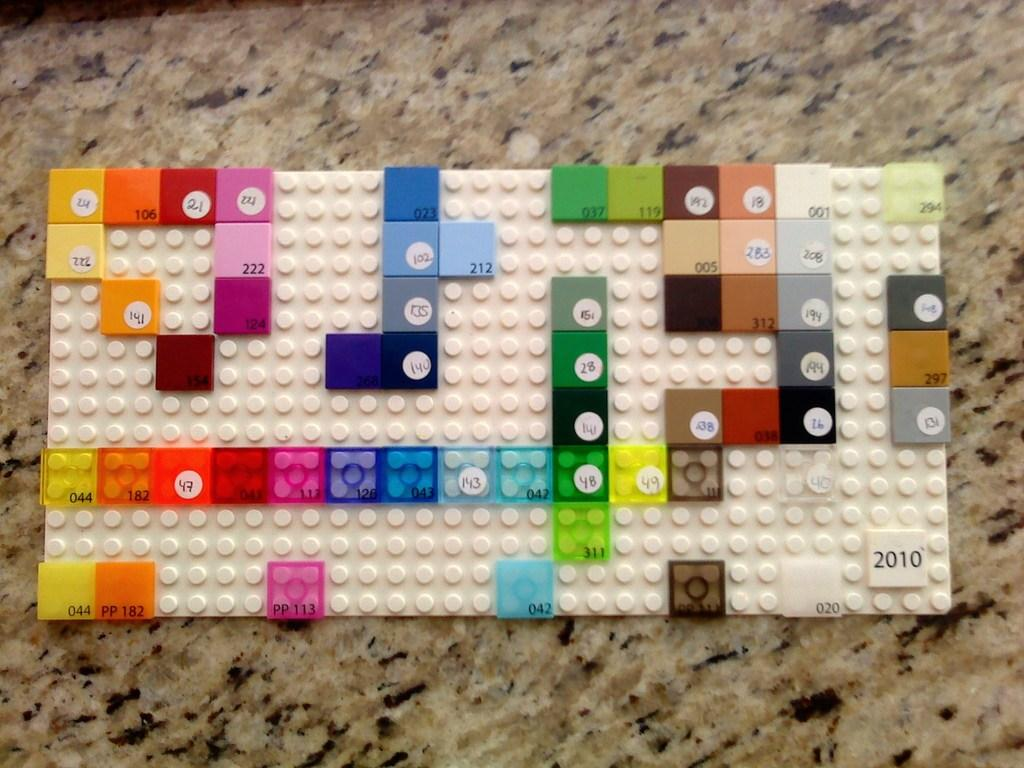What type of toy is present in the image? There are lego bricks in the image. What is the surface on which the lego bricks are placed? The lego bricks are on a stone surface. What type of church can be seen in the image? There is no church present in the image; it features lego bricks on a stone surface. What act are the lego bricks performing in the image? Lego bricks are inanimate objects and cannot perform acts. 